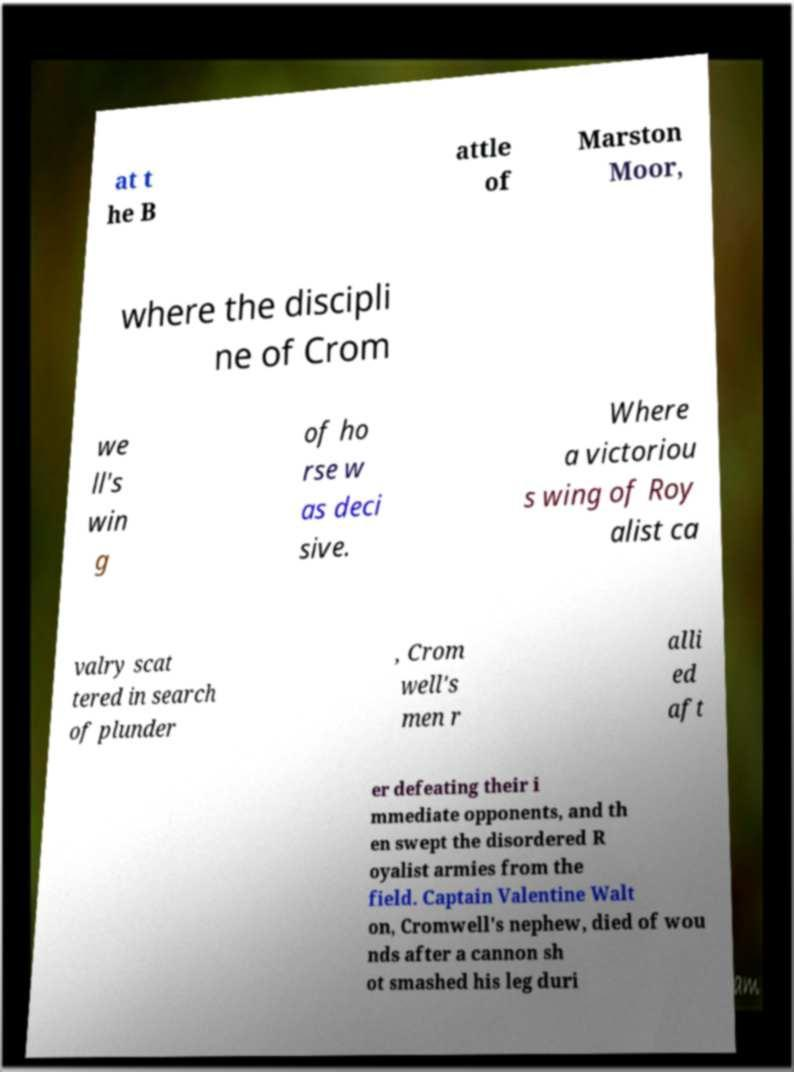Could you assist in decoding the text presented in this image and type it out clearly? at t he B attle of Marston Moor, where the discipli ne of Crom we ll's win g of ho rse w as deci sive. Where a victoriou s wing of Roy alist ca valry scat tered in search of plunder , Crom well's men r alli ed aft er defeating their i mmediate opponents, and th en swept the disordered R oyalist armies from the field. Captain Valentine Walt on, Cromwell's nephew, died of wou nds after a cannon sh ot smashed his leg duri 